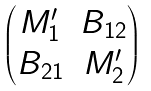<formula> <loc_0><loc_0><loc_500><loc_500>\begin{pmatrix} M ^ { \prime } _ { 1 } & B _ { 1 2 } \\ B _ { 2 1 } & M ^ { \prime } _ { 2 } \\ \end{pmatrix}</formula> 